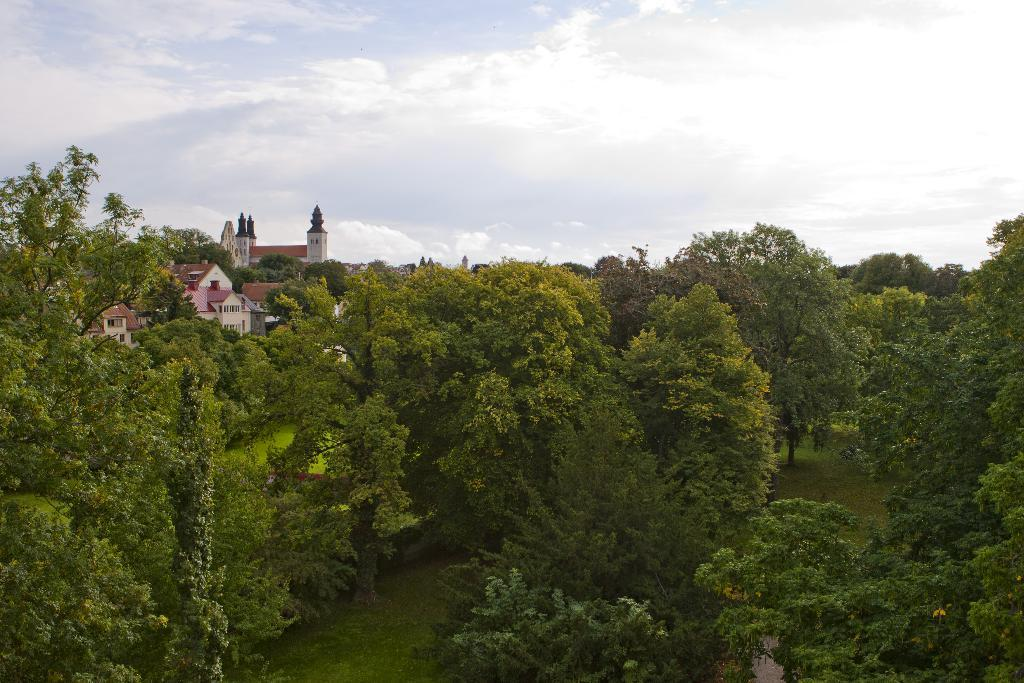What is the main feature of the image? The main feature of the image is the many trees. What can be seen behind the trees? There is a building behind the trees. What is the condition of the sky in the image? The sky is covered with clouds. Is there a veil covering the trees in the image? No, there is no veil present in the image. What type of metal can be seen in the image? There is no metal visible in the image; it primarily features trees, a building, and clouds. 